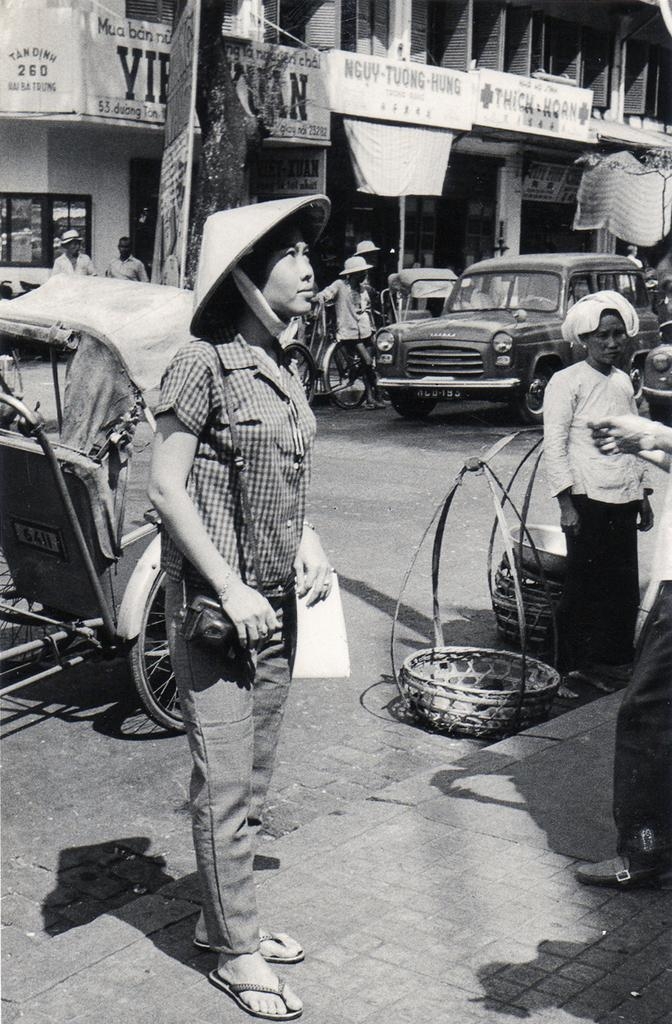What is happening in the image involving people? There is a group of people standing in the image. What else can be seen on the road in the image? There are vehicles on the road in the image. What type of structures are present in the image? There are buildings in the image. Are there any additional details about the buildings? Yes, there are banners attached to the buildings in the image. How is the image presented in terms of color? The image is in black and white. What type of sack is being used to cover the vehicles in the image? There is no sack present in the image, and the vehicles are not covered. Can you see any veils being worn by the people in the image? There is no mention of veils in the image, and no indication that the people are wearing them. 